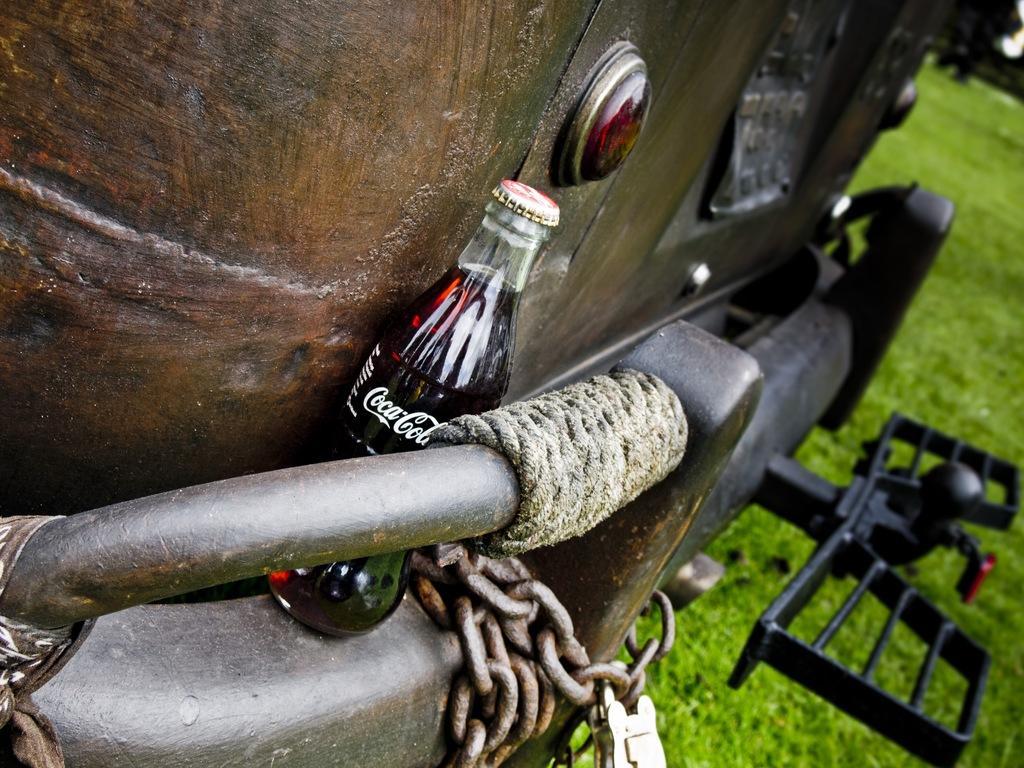Describe this image in one or two sentences. In this image I see a bottle, rope and a chain, I can also see the green grass. 